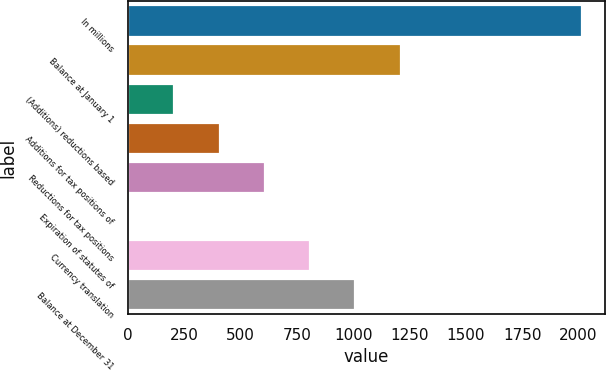Convert chart. <chart><loc_0><loc_0><loc_500><loc_500><bar_chart><fcel>In millions<fcel>Balance at January 1<fcel>(Additions) reductions based<fcel>Additions for tax positions of<fcel>Reductions for tax positions<fcel>Expiration of statutes of<fcel>Currency translation<fcel>Balance at December 31<nl><fcel>2015<fcel>1210.6<fcel>205.1<fcel>406.2<fcel>607.3<fcel>4<fcel>808.4<fcel>1009.5<nl></chart> 